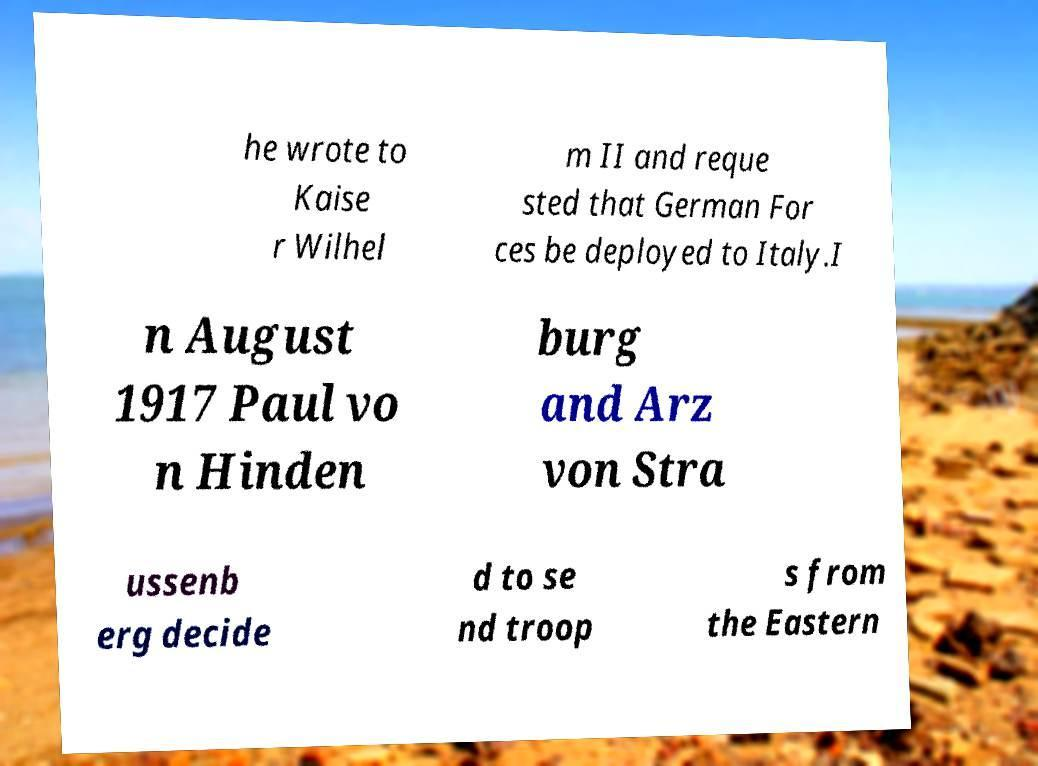For documentation purposes, I need the text within this image transcribed. Could you provide that? he wrote to Kaise r Wilhel m II and reque sted that German For ces be deployed to Italy.I n August 1917 Paul vo n Hinden burg and Arz von Stra ussenb erg decide d to se nd troop s from the Eastern 